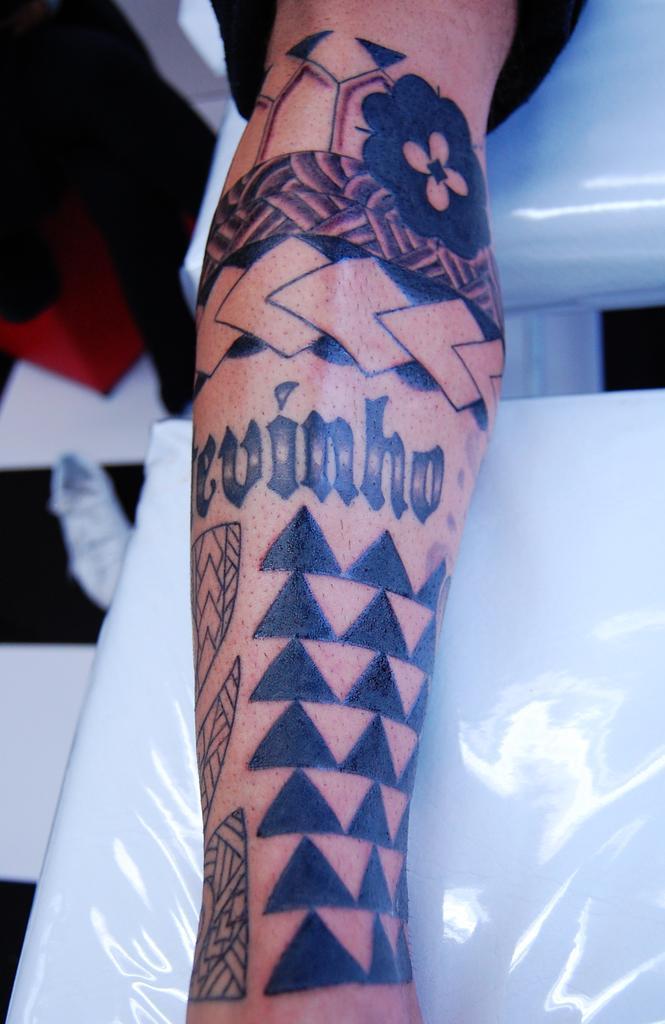In one or two sentences, can you explain what this image depicts? In this image I can see a person hand, on the hand I can see a tattoo and the hand is on some white color surface. 